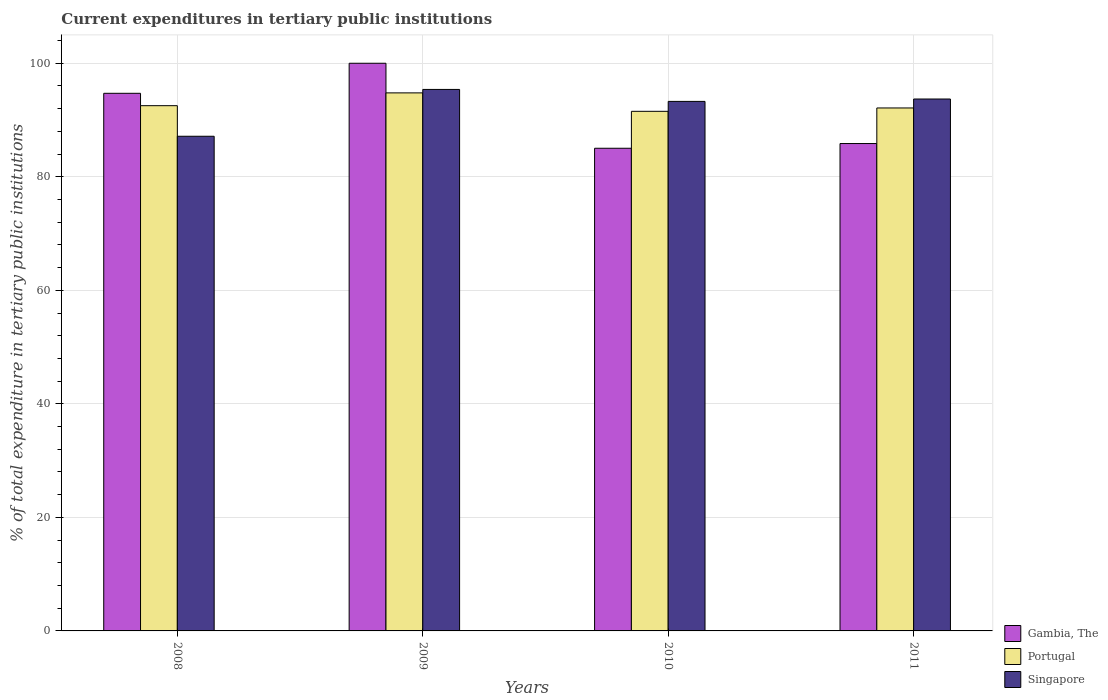How many different coloured bars are there?
Make the answer very short. 3. How many groups of bars are there?
Offer a terse response. 4. Are the number of bars per tick equal to the number of legend labels?
Make the answer very short. Yes. Are the number of bars on each tick of the X-axis equal?
Give a very brief answer. Yes. How many bars are there on the 2nd tick from the left?
Provide a short and direct response. 3. How many bars are there on the 2nd tick from the right?
Provide a succinct answer. 3. What is the label of the 2nd group of bars from the left?
Your response must be concise. 2009. In how many cases, is the number of bars for a given year not equal to the number of legend labels?
Make the answer very short. 0. What is the current expenditures in tertiary public institutions in Gambia, The in 2010?
Your answer should be compact. 85.03. Across all years, what is the minimum current expenditures in tertiary public institutions in Portugal?
Your response must be concise. 91.53. In which year was the current expenditures in tertiary public institutions in Portugal maximum?
Offer a terse response. 2009. What is the total current expenditures in tertiary public institutions in Portugal in the graph?
Ensure brevity in your answer.  370.97. What is the difference between the current expenditures in tertiary public institutions in Gambia, The in 2009 and that in 2011?
Provide a short and direct response. 14.14. What is the difference between the current expenditures in tertiary public institutions in Portugal in 2011 and the current expenditures in tertiary public institutions in Singapore in 2009?
Give a very brief answer. -3.27. What is the average current expenditures in tertiary public institutions in Portugal per year?
Offer a terse response. 92.74. In the year 2009, what is the difference between the current expenditures in tertiary public institutions in Portugal and current expenditures in tertiary public institutions in Singapore?
Provide a short and direct response. -0.61. What is the ratio of the current expenditures in tertiary public institutions in Gambia, The in 2008 to that in 2010?
Offer a terse response. 1.11. What is the difference between the highest and the second highest current expenditures in tertiary public institutions in Portugal?
Your response must be concise. 2.25. What is the difference between the highest and the lowest current expenditures in tertiary public institutions in Portugal?
Offer a very short reply. 3.25. In how many years, is the current expenditures in tertiary public institutions in Singapore greater than the average current expenditures in tertiary public institutions in Singapore taken over all years?
Give a very brief answer. 3. Is the sum of the current expenditures in tertiary public institutions in Singapore in 2009 and 2010 greater than the maximum current expenditures in tertiary public institutions in Gambia, The across all years?
Ensure brevity in your answer.  Yes. What does the 2nd bar from the left in 2010 represents?
Provide a short and direct response. Portugal. What does the 2nd bar from the right in 2010 represents?
Your response must be concise. Portugal. How many years are there in the graph?
Give a very brief answer. 4. What is the difference between two consecutive major ticks on the Y-axis?
Offer a very short reply. 20. Are the values on the major ticks of Y-axis written in scientific E-notation?
Offer a very short reply. No. Where does the legend appear in the graph?
Offer a terse response. Bottom right. How many legend labels are there?
Keep it short and to the point. 3. What is the title of the graph?
Provide a succinct answer. Current expenditures in tertiary public institutions. What is the label or title of the Y-axis?
Offer a terse response. % of total expenditure in tertiary public institutions. What is the % of total expenditure in tertiary public institutions in Gambia, The in 2008?
Keep it short and to the point. 94.71. What is the % of total expenditure in tertiary public institutions of Portugal in 2008?
Make the answer very short. 92.53. What is the % of total expenditure in tertiary public institutions of Singapore in 2008?
Your response must be concise. 87.14. What is the % of total expenditure in tertiary public institutions of Gambia, The in 2009?
Ensure brevity in your answer.  100. What is the % of total expenditure in tertiary public institutions in Portugal in 2009?
Your response must be concise. 94.78. What is the % of total expenditure in tertiary public institutions of Singapore in 2009?
Your answer should be very brief. 95.39. What is the % of total expenditure in tertiary public institutions of Gambia, The in 2010?
Your answer should be compact. 85.03. What is the % of total expenditure in tertiary public institutions of Portugal in 2010?
Make the answer very short. 91.53. What is the % of total expenditure in tertiary public institutions of Singapore in 2010?
Your response must be concise. 93.28. What is the % of total expenditure in tertiary public institutions in Gambia, The in 2011?
Ensure brevity in your answer.  85.86. What is the % of total expenditure in tertiary public institutions in Portugal in 2011?
Provide a succinct answer. 92.12. What is the % of total expenditure in tertiary public institutions of Singapore in 2011?
Give a very brief answer. 93.7. Across all years, what is the maximum % of total expenditure in tertiary public institutions of Portugal?
Provide a succinct answer. 94.78. Across all years, what is the maximum % of total expenditure in tertiary public institutions of Singapore?
Provide a short and direct response. 95.39. Across all years, what is the minimum % of total expenditure in tertiary public institutions in Gambia, The?
Ensure brevity in your answer.  85.03. Across all years, what is the minimum % of total expenditure in tertiary public institutions of Portugal?
Offer a terse response. 91.53. Across all years, what is the minimum % of total expenditure in tertiary public institutions in Singapore?
Offer a terse response. 87.14. What is the total % of total expenditure in tertiary public institutions in Gambia, The in the graph?
Offer a terse response. 365.59. What is the total % of total expenditure in tertiary public institutions of Portugal in the graph?
Keep it short and to the point. 370.97. What is the total % of total expenditure in tertiary public institutions in Singapore in the graph?
Ensure brevity in your answer.  369.51. What is the difference between the % of total expenditure in tertiary public institutions in Gambia, The in 2008 and that in 2009?
Keep it short and to the point. -5.29. What is the difference between the % of total expenditure in tertiary public institutions in Portugal in 2008 and that in 2009?
Keep it short and to the point. -2.25. What is the difference between the % of total expenditure in tertiary public institutions in Singapore in 2008 and that in 2009?
Your answer should be very brief. -8.25. What is the difference between the % of total expenditure in tertiary public institutions in Gambia, The in 2008 and that in 2010?
Ensure brevity in your answer.  9.68. What is the difference between the % of total expenditure in tertiary public institutions of Singapore in 2008 and that in 2010?
Your answer should be compact. -6.14. What is the difference between the % of total expenditure in tertiary public institutions of Gambia, The in 2008 and that in 2011?
Your answer should be very brief. 8.85. What is the difference between the % of total expenditure in tertiary public institutions in Portugal in 2008 and that in 2011?
Keep it short and to the point. 0.4. What is the difference between the % of total expenditure in tertiary public institutions of Singapore in 2008 and that in 2011?
Make the answer very short. -6.56. What is the difference between the % of total expenditure in tertiary public institutions in Gambia, The in 2009 and that in 2010?
Offer a terse response. 14.97. What is the difference between the % of total expenditure in tertiary public institutions in Portugal in 2009 and that in 2010?
Ensure brevity in your answer.  3.25. What is the difference between the % of total expenditure in tertiary public institutions in Singapore in 2009 and that in 2010?
Offer a terse response. 2.11. What is the difference between the % of total expenditure in tertiary public institutions in Gambia, The in 2009 and that in 2011?
Your answer should be very brief. 14.14. What is the difference between the % of total expenditure in tertiary public institutions of Portugal in 2009 and that in 2011?
Offer a very short reply. 2.66. What is the difference between the % of total expenditure in tertiary public institutions of Singapore in 2009 and that in 2011?
Make the answer very short. 1.69. What is the difference between the % of total expenditure in tertiary public institutions in Gambia, The in 2010 and that in 2011?
Provide a succinct answer. -0.83. What is the difference between the % of total expenditure in tertiary public institutions of Portugal in 2010 and that in 2011?
Give a very brief answer. -0.59. What is the difference between the % of total expenditure in tertiary public institutions of Singapore in 2010 and that in 2011?
Your answer should be compact. -0.42. What is the difference between the % of total expenditure in tertiary public institutions in Gambia, The in 2008 and the % of total expenditure in tertiary public institutions in Portugal in 2009?
Your answer should be compact. -0.07. What is the difference between the % of total expenditure in tertiary public institutions in Gambia, The in 2008 and the % of total expenditure in tertiary public institutions in Singapore in 2009?
Give a very brief answer. -0.68. What is the difference between the % of total expenditure in tertiary public institutions in Portugal in 2008 and the % of total expenditure in tertiary public institutions in Singapore in 2009?
Provide a short and direct response. -2.86. What is the difference between the % of total expenditure in tertiary public institutions in Gambia, The in 2008 and the % of total expenditure in tertiary public institutions in Portugal in 2010?
Give a very brief answer. 3.17. What is the difference between the % of total expenditure in tertiary public institutions in Gambia, The in 2008 and the % of total expenditure in tertiary public institutions in Singapore in 2010?
Give a very brief answer. 1.43. What is the difference between the % of total expenditure in tertiary public institutions in Portugal in 2008 and the % of total expenditure in tertiary public institutions in Singapore in 2010?
Your answer should be compact. -0.75. What is the difference between the % of total expenditure in tertiary public institutions in Gambia, The in 2008 and the % of total expenditure in tertiary public institutions in Portugal in 2011?
Your response must be concise. 2.58. What is the difference between the % of total expenditure in tertiary public institutions of Portugal in 2008 and the % of total expenditure in tertiary public institutions of Singapore in 2011?
Keep it short and to the point. -1.18. What is the difference between the % of total expenditure in tertiary public institutions in Gambia, The in 2009 and the % of total expenditure in tertiary public institutions in Portugal in 2010?
Keep it short and to the point. 8.47. What is the difference between the % of total expenditure in tertiary public institutions of Gambia, The in 2009 and the % of total expenditure in tertiary public institutions of Singapore in 2010?
Your response must be concise. 6.72. What is the difference between the % of total expenditure in tertiary public institutions in Portugal in 2009 and the % of total expenditure in tertiary public institutions in Singapore in 2010?
Offer a terse response. 1.5. What is the difference between the % of total expenditure in tertiary public institutions in Gambia, The in 2009 and the % of total expenditure in tertiary public institutions in Portugal in 2011?
Give a very brief answer. 7.88. What is the difference between the % of total expenditure in tertiary public institutions in Gambia, The in 2009 and the % of total expenditure in tertiary public institutions in Singapore in 2011?
Give a very brief answer. 6.3. What is the difference between the % of total expenditure in tertiary public institutions of Portugal in 2009 and the % of total expenditure in tertiary public institutions of Singapore in 2011?
Your answer should be very brief. 1.08. What is the difference between the % of total expenditure in tertiary public institutions of Gambia, The in 2010 and the % of total expenditure in tertiary public institutions of Portugal in 2011?
Offer a very short reply. -7.1. What is the difference between the % of total expenditure in tertiary public institutions of Gambia, The in 2010 and the % of total expenditure in tertiary public institutions of Singapore in 2011?
Your response must be concise. -8.68. What is the difference between the % of total expenditure in tertiary public institutions in Portugal in 2010 and the % of total expenditure in tertiary public institutions in Singapore in 2011?
Offer a terse response. -2.17. What is the average % of total expenditure in tertiary public institutions of Gambia, The per year?
Provide a succinct answer. 91.4. What is the average % of total expenditure in tertiary public institutions of Portugal per year?
Your response must be concise. 92.74. What is the average % of total expenditure in tertiary public institutions in Singapore per year?
Provide a succinct answer. 92.38. In the year 2008, what is the difference between the % of total expenditure in tertiary public institutions in Gambia, The and % of total expenditure in tertiary public institutions in Portugal?
Make the answer very short. 2.18. In the year 2008, what is the difference between the % of total expenditure in tertiary public institutions in Gambia, The and % of total expenditure in tertiary public institutions in Singapore?
Provide a succinct answer. 7.57. In the year 2008, what is the difference between the % of total expenditure in tertiary public institutions of Portugal and % of total expenditure in tertiary public institutions of Singapore?
Offer a terse response. 5.39. In the year 2009, what is the difference between the % of total expenditure in tertiary public institutions in Gambia, The and % of total expenditure in tertiary public institutions in Portugal?
Your response must be concise. 5.22. In the year 2009, what is the difference between the % of total expenditure in tertiary public institutions in Gambia, The and % of total expenditure in tertiary public institutions in Singapore?
Give a very brief answer. 4.61. In the year 2009, what is the difference between the % of total expenditure in tertiary public institutions of Portugal and % of total expenditure in tertiary public institutions of Singapore?
Offer a very short reply. -0.61. In the year 2010, what is the difference between the % of total expenditure in tertiary public institutions in Gambia, The and % of total expenditure in tertiary public institutions in Portugal?
Give a very brief answer. -6.51. In the year 2010, what is the difference between the % of total expenditure in tertiary public institutions in Gambia, The and % of total expenditure in tertiary public institutions in Singapore?
Give a very brief answer. -8.25. In the year 2010, what is the difference between the % of total expenditure in tertiary public institutions of Portugal and % of total expenditure in tertiary public institutions of Singapore?
Your answer should be very brief. -1.75. In the year 2011, what is the difference between the % of total expenditure in tertiary public institutions in Gambia, The and % of total expenditure in tertiary public institutions in Portugal?
Provide a succinct answer. -6.27. In the year 2011, what is the difference between the % of total expenditure in tertiary public institutions in Gambia, The and % of total expenditure in tertiary public institutions in Singapore?
Make the answer very short. -7.85. In the year 2011, what is the difference between the % of total expenditure in tertiary public institutions of Portugal and % of total expenditure in tertiary public institutions of Singapore?
Give a very brief answer. -1.58. What is the ratio of the % of total expenditure in tertiary public institutions of Gambia, The in 2008 to that in 2009?
Offer a very short reply. 0.95. What is the ratio of the % of total expenditure in tertiary public institutions in Portugal in 2008 to that in 2009?
Make the answer very short. 0.98. What is the ratio of the % of total expenditure in tertiary public institutions in Singapore in 2008 to that in 2009?
Provide a succinct answer. 0.91. What is the ratio of the % of total expenditure in tertiary public institutions in Gambia, The in 2008 to that in 2010?
Your answer should be compact. 1.11. What is the ratio of the % of total expenditure in tertiary public institutions of Portugal in 2008 to that in 2010?
Ensure brevity in your answer.  1.01. What is the ratio of the % of total expenditure in tertiary public institutions of Singapore in 2008 to that in 2010?
Give a very brief answer. 0.93. What is the ratio of the % of total expenditure in tertiary public institutions in Gambia, The in 2008 to that in 2011?
Give a very brief answer. 1.1. What is the ratio of the % of total expenditure in tertiary public institutions of Portugal in 2008 to that in 2011?
Ensure brevity in your answer.  1. What is the ratio of the % of total expenditure in tertiary public institutions of Gambia, The in 2009 to that in 2010?
Keep it short and to the point. 1.18. What is the ratio of the % of total expenditure in tertiary public institutions of Portugal in 2009 to that in 2010?
Make the answer very short. 1.04. What is the ratio of the % of total expenditure in tertiary public institutions of Singapore in 2009 to that in 2010?
Make the answer very short. 1.02. What is the ratio of the % of total expenditure in tertiary public institutions of Gambia, The in 2009 to that in 2011?
Make the answer very short. 1.16. What is the ratio of the % of total expenditure in tertiary public institutions in Portugal in 2009 to that in 2011?
Keep it short and to the point. 1.03. What is the ratio of the % of total expenditure in tertiary public institutions of Gambia, The in 2010 to that in 2011?
Your answer should be very brief. 0.99. What is the ratio of the % of total expenditure in tertiary public institutions of Portugal in 2010 to that in 2011?
Provide a succinct answer. 0.99. What is the ratio of the % of total expenditure in tertiary public institutions in Singapore in 2010 to that in 2011?
Ensure brevity in your answer.  1. What is the difference between the highest and the second highest % of total expenditure in tertiary public institutions in Gambia, The?
Your answer should be compact. 5.29. What is the difference between the highest and the second highest % of total expenditure in tertiary public institutions in Portugal?
Provide a short and direct response. 2.25. What is the difference between the highest and the second highest % of total expenditure in tertiary public institutions of Singapore?
Make the answer very short. 1.69. What is the difference between the highest and the lowest % of total expenditure in tertiary public institutions in Gambia, The?
Your answer should be very brief. 14.97. What is the difference between the highest and the lowest % of total expenditure in tertiary public institutions of Portugal?
Offer a very short reply. 3.25. What is the difference between the highest and the lowest % of total expenditure in tertiary public institutions in Singapore?
Offer a very short reply. 8.25. 